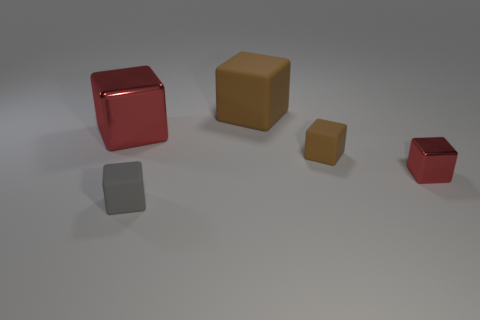What number of matte objects are either red things or big brown objects?
Your response must be concise. 1. What is the block right of the brown rubber cube that is in front of the large red thing made of?
Give a very brief answer. Metal. What material is the other cube that is the same color as the big matte block?
Make the answer very short. Rubber. What is the color of the large matte object?
Your answer should be very brief. Brown. Is there a red metal thing in front of the small rubber thing behind the tiny gray block?
Provide a short and direct response. Yes. What material is the small brown block?
Provide a succinct answer. Rubber. Is the material of the big thing that is to the left of the small gray rubber object the same as the cube that is in front of the small red metallic block?
Your answer should be very brief. No. Are there any other things that have the same color as the large metal cube?
Provide a short and direct response. Yes. There is another big object that is the same shape as the big red object; what is its color?
Make the answer very short. Brown. There is a rubber thing that is both in front of the large red block and behind the gray cube; what size is it?
Your answer should be very brief. Small. 